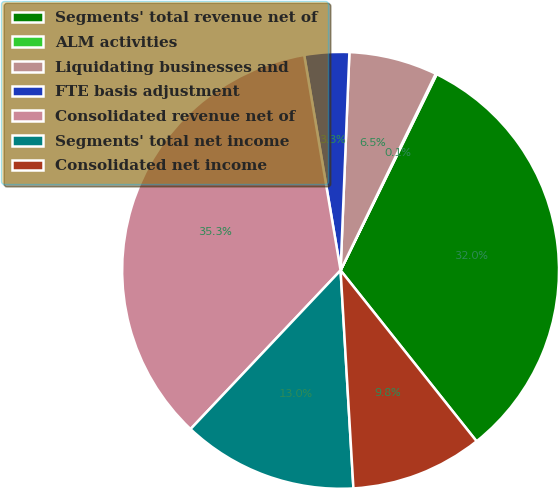Convert chart to OTSL. <chart><loc_0><loc_0><loc_500><loc_500><pie_chart><fcel>Segments' total revenue net of<fcel>ALM activities<fcel>Liquidating businesses and<fcel>FTE basis adjustment<fcel>Consolidated revenue net of<fcel>Segments' total net income<fcel>Consolidated net income<nl><fcel>32.05%<fcel>0.08%<fcel>6.53%<fcel>3.31%<fcel>35.28%<fcel>12.99%<fcel>9.76%<nl></chart> 